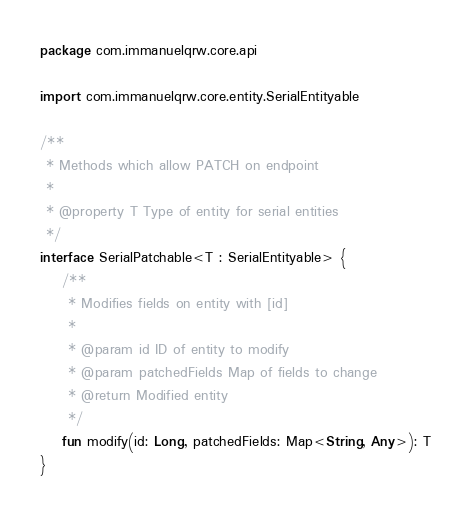<code> <loc_0><loc_0><loc_500><loc_500><_Kotlin_>package com.immanuelqrw.core.api

import com.immanuelqrw.core.entity.SerialEntityable

/**
 * Methods which allow PATCH on endpoint
 *
 * @property T Type of entity for serial entities
 */
interface SerialPatchable<T : SerialEntityable> {
    /**
     * Modifies fields on entity with [id]
     *
     * @param id ID of entity to modify
     * @param patchedFields Map of fields to change
     * @return Modified entity
     */
    fun modify(id: Long, patchedFields: Map<String, Any>): T
}
</code> 